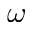<formula> <loc_0><loc_0><loc_500><loc_500>\omega</formula> 